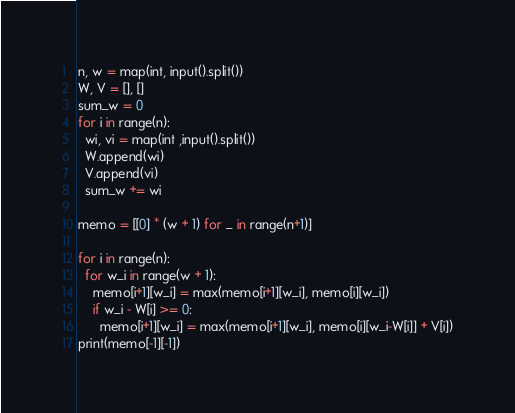Convert code to text. <code><loc_0><loc_0><loc_500><loc_500><_Python_>n, w = map(int, input().split())
W, V = [], []
sum_w = 0
for i in range(n):
  wi, vi = map(int ,input().split())
  W.append(wi)
  V.append(vi)
  sum_w += wi

memo = [[0] * (w + 1) for _ in range(n+1)]

for i in range(n):
  for w_i in range(w + 1):
    memo[i+1][w_i] = max(memo[i+1][w_i], memo[i][w_i])
    if w_i - W[i] >= 0:
      memo[i+1][w_i] = max(memo[i+1][w_i], memo[i][w_i-W[i]] + V[i])
print(memo[-1][-1])</code> 